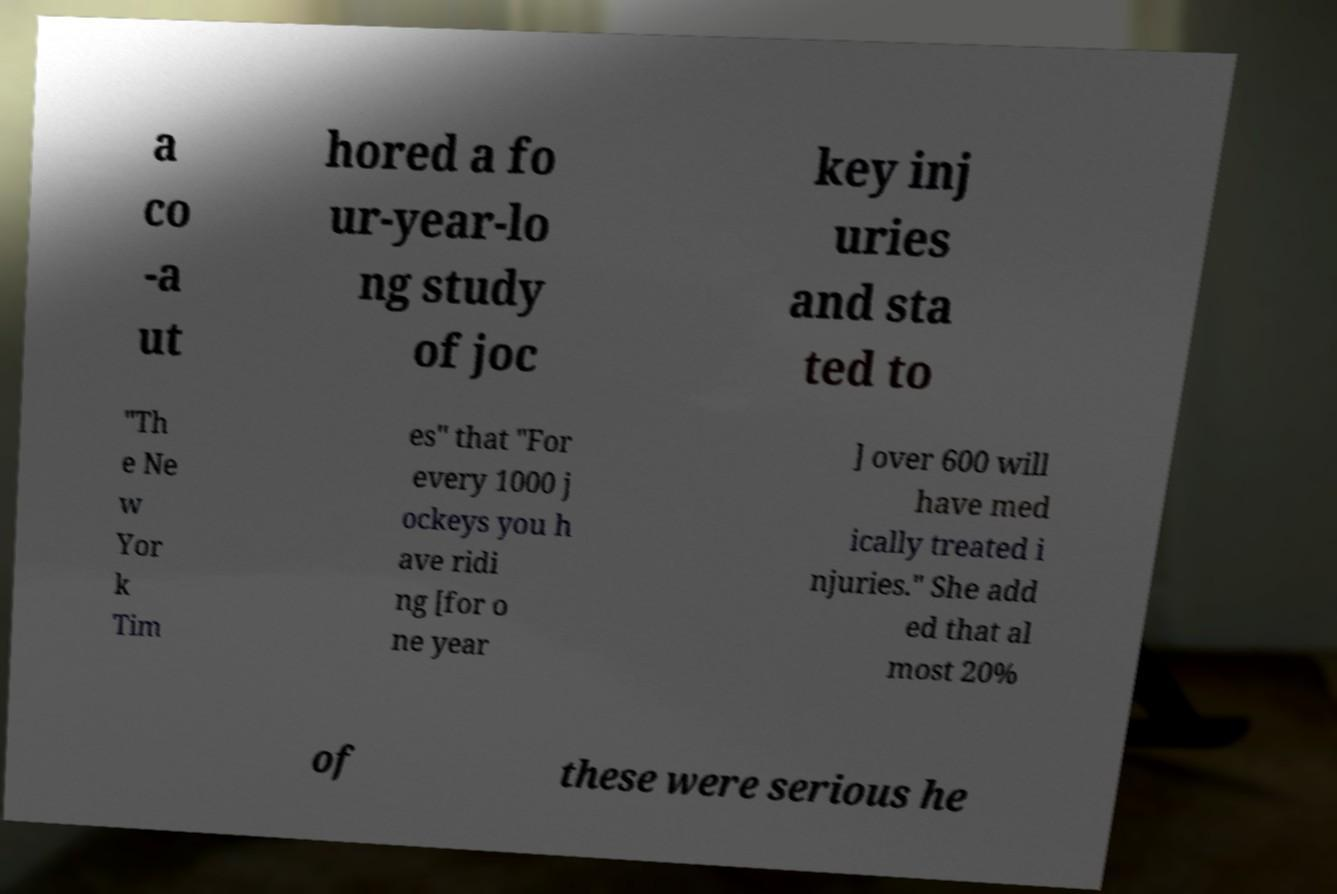Could you assist in decoding the text presented in this image and type it out clearly? a co -a ut hored a fo ur-year-lo ng study of joc key inj uries and sta ted to "Th e Ne w Yor k Tim es" that "For every 1000 j ockeys you h ave ridi ng [for o ne year ] over 600 will have med ically treated i njuries." She add ed that al most 20% of these were serious he 